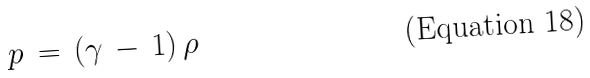<formula> <loc_0><loc_0><loc_500><loc_500>p \, = \, ( \gamma \, - \, 1 ) \, \rho</formula> 